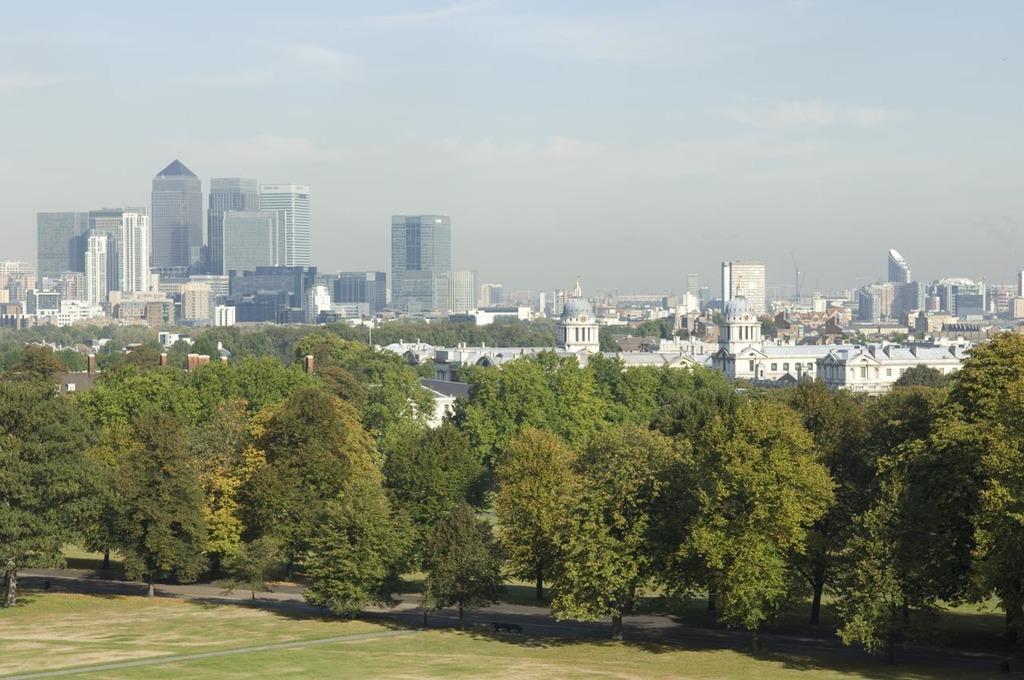Please provide a concise description of this image. In this image in the front there's grass on the ground. In the center there are trees. In the background there are buildings and the sky is cloudy. 